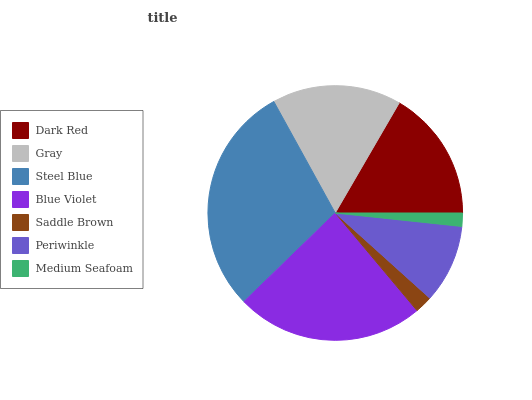Is Medium Seafoam the minimum?
Answer yes or no. Yes. Is Steel Blue the maximum?
Answer yes or no. Yes. Is Gray the minimum?
Answer yes or no. No. Is Gray the maximum?
Answer yes or no. No. Is Dark Red greater than Gray?
Answer yes or no. Yes. Is Gray less than Dark Red?
Answer yes or no. Yes. Is Gray greater than Dark Red?
Answer yes or no. No. Is Dark Red less than Gray?
Answer yes or no. No. Is Gray the high median?
Answer yes or no. Yes. Is Gray the low median?
Answer yes or no. Yes. Is Medium Seafoam the high median?
Answer yes or no. No. Is Periwinkle the low median?
Answer yes or no. No. 